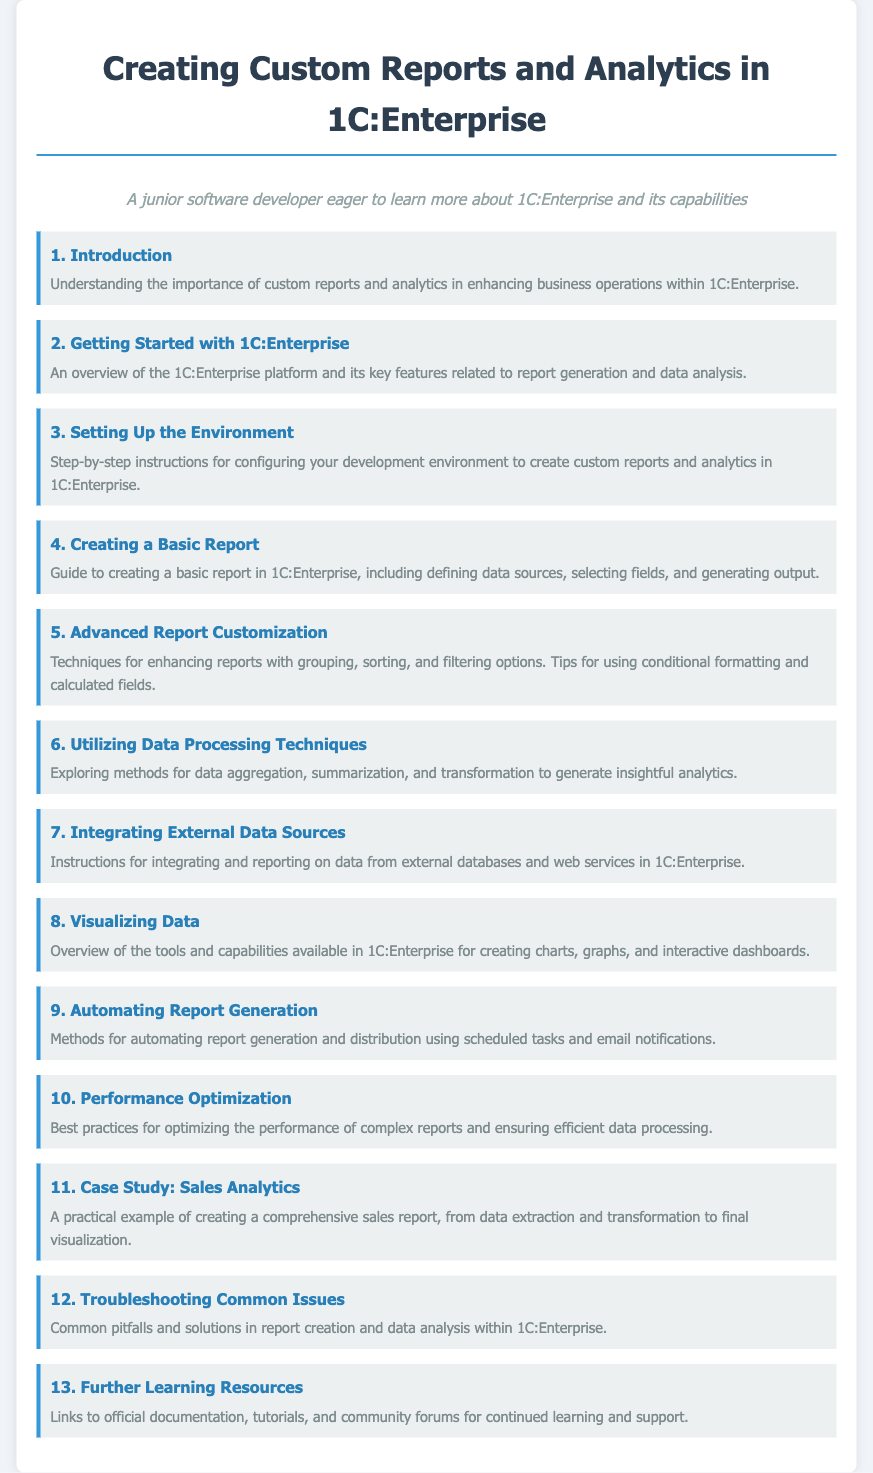What is the title of the document? The title is explicitly mentioned at the top of the document within the header.
Answer: Creating Custom Reports and Analytics in 1C:Enterprise How many sections are there in the document? The number of sections can be counted from the visible section list in the content.
Answer: 13 What is the main focus of section 5? The content of section 5 describes advanced techniques related to reports, as indicated by its title.
Answer: Advanced Report Customization Which section covers troubleshooting issues? The section dedicated to troubleshooting is listed among the other sections and focuses explicitly on issues.
Answer: Troubleshooting Common Issues What does section 11 provide? Section 11 gives a practical application case, specifically exploring a certain aspect of report creation.
Answer: Case Study: Sales Analytics What is the purpose of section 9? The title of section 9 indicates that it deals with methods related to report generation processes.
Answer: Automating Report Generation What kind of resources are listed in section 13? This section refers to additional educational materials and community support.
Answer: Further Learning Resources What is discussed in section 8? Section 8 highlights the visualization capabilities within the document's context, as indicated by its title.
Answer: Visualizing Data What is the theme of section 6? The title of section 6 suggests that it discusses data techniques and methods related to analytics.
Answer: Utilizing Data Processing Techniques 